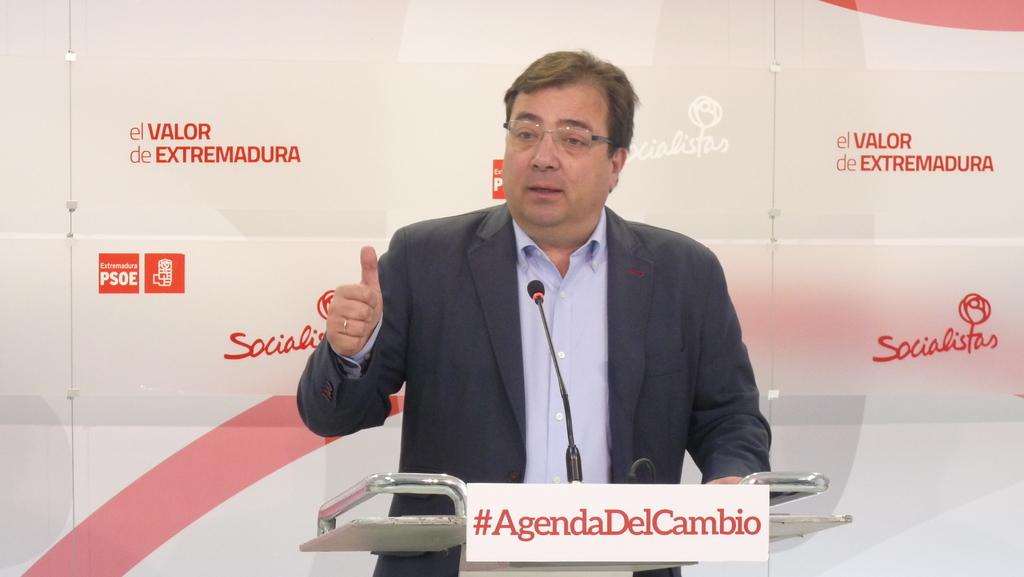Who or what is the main subject of the image? There is a person in the image. What object is the person standing near? There is a podium in the image. What device is visible near the person? A microphone is present in the image. What type of information is displayed on the board in the image? There is a board with text in the image. Can you describe the background of the image? There is a board with text in the background of the image. What type of seed is being planted by the person in the image? There is no seed or planting activity present in the image. Who is the owner of the podium in the image? The image does not provide information about the ownership of the podium. 